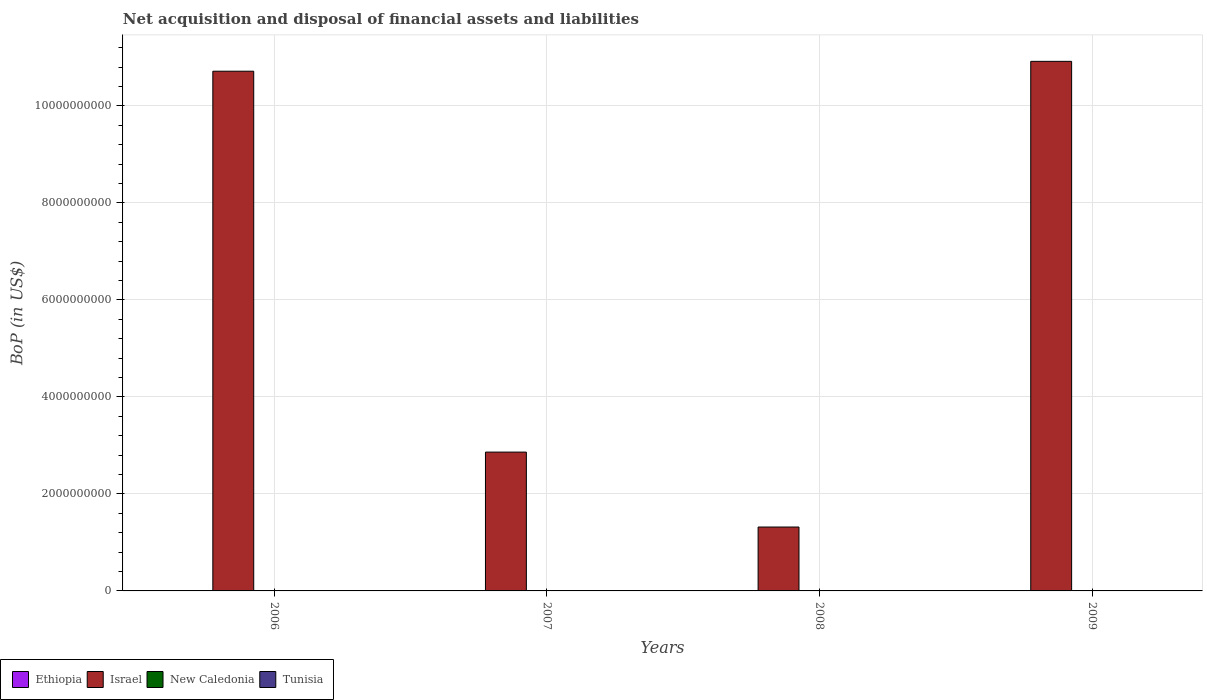Are the number of bars per tick equal to the number of legend labels?
Offer a very short reply. No. How many bars are there on the 4th tick from the left?
Your response must be concise. 1. How many bars are there on the 3rd tick from the right?
Provide a succinct answer. 1. In how many cases, is the number of bars for a given year not equal to the number of legend labels?
Ensure brevity in your answer.  4. In which year was the Balance of Payments in Israel maximum?
Provide a short and direct response. 2009. What is the total Balance of Payments in Ethiopia in the graph?
Your response must be concise. 0. What is the difference between the Balance of Payments in Israel in 2006 and that in 2007?
Provide a succinct answer. 7.85e+09. What is the difference between the Balance of Payments in Israel in 2008 and the Balance of Payments in New Caledonia in 2006?
Offer a very short reply. 1.32e+09. In how many years, is the Balance of Payments in New Caledonia greater than 1200000000 US$?
Offer a very short reply. 0. What is the ratio of the Balance of Payments in Israel in 2007 to that in 2008?
Provide a succinct answer. 2.17. What is the difference between the highest and the lowest Balance of Payments in Israel?
Provide a short and direct response. 9.60e+09. Is it the case that in every year, the sum of the Balance of Payments in Israel and Balance of Payments in New Caledonia is greater than the sum of Balance of Payments in Tunisia and Balance of Payments in Ethiopia?
Your response must be concise. Yes. What is the difference between two consecutive major ticks on the Y-axis?
Offer a terse response. 2.00e+09. Are the values on the major ticks of Y-axis written in scientific E-notation?
Keep it short and to the point. No. Does the graph contain grids?
Ensure brevity in your answer.  Yes. Where does the legend appear in the graph?
Make the answer very short. Bottom left. How are the legend labels stacked?
Keep it short and to the point. Horizontal. What is the title of the graph?
Your response must be concise. Net acquisition and disposal of financial assets and liabilities. What is the label or title of the X-axis?
Offer a terse response. Years. What is the label or title of the Y-axis?
Provide a succinct answer. BoP (in US$). What is the BoP (in US$) in Ethiopia in 2006?
Keep it short and to the point. 0. What is the BoP (in US$) in Israel in 2006?
Keep it short and to the point. 1.07e+1. What is the BoP (in US$) in New Caledonia in 2006?
Offer a very short reply. 0. What is the BoP (in US$) of Ethiopia in 2007?
Offer a terse response. 0. What is the BoP (in US$) of Israel in 2007?
Provide a succinct answer. 2.86e+09. What is the BoP (in US$) of New Caledonia in 2007?
Keep it short and to the point. 0. What is the BoP (in US$) of Tunisia in 2007?
Give a very brief answer. 0. What is the BoP (in US$) of Ethiopia in 2008?
Ensure brevity in your answer.  0. What is the BoP (in US$) in Israel in 2008?
Give a very brief answer. 1.32e+09. What is the BoP (in US$) in New Caledonia in 2008?
Your answer should be very brief. 0. What is the BoP (in US$) of Israel in 2009?
Your answer should be compact. 1.09e+1. Across all years, what is the maximum BoP (in US$) of Israel?
Your answer should be very brief. 1.09e+1. Across all years, what is the minimum BoP (in US$) in Israel?
Keep it short and to the point. 1.32e+09. What is the total BoP (in US$) of Ethiopia in the graph?
Provide a succinct answer. 0. What is the total BoP (in US$) in Israel in the graph?
Offer a very short reply. 2.58e+1. What is the total BoP (in US$) in New Caledonia in the graph?
Offer a very short reply. 0. What is the difference between the BoP (in US$) in Israel in 2006 and that in 2007?
Give a very brief answer. 7.85e+09. What is the difference between the BoP (in US$) in Israel in 2006 and that in 2008?
Ensure brevity in your answer.  9.40e+09. What is the difference between the BoP (in US$) of Israel in 2006 and that in 2009?
Make the answer very short. -2.03e+08. What is the difference between the BoP (in US$) of Israel in 2007 and that in 2008?
Your answer should be very brief. 1.54e+09. What is the difference between the BoP (in US$) of Israel in 2007 and that in 2009?
Ensure brevity in your answer.  -8.06e+09. What is the difference between the BoP (in US$) of Israel in 2008 and that in 2009?
Your answer should be compact. -9.60e+09. What is the average BoP (in US$) in Ethiopia per year?
Provide a short and direct response. 0. What is the average BoP (in US$) of Israel per year?
Keep it short and to the point. 6.45e+09. What is the ratio of the BoP (in US$) in Israel in 2006 to that in 2007?
Keep it short and to the point. 3.74. What is the ratio of the BoP (in US$) of Israel in 2006 to that in 2008?
Give a very brief answer. 8.13. What is the ratio of the BoP (in US$) of Israel in 2006 to that in 2009?
Provide a short and direct response. 0.98. What is the ratio of the BoP (in US$) in Israel in 2007 to that in 2008?
Ensure brevity in your answer.  2.17. What is the ratio of the BoP (in US$) in Israel in 2007 to that in 2009?
Keep it short and to the point. 0.26. What is the ratio of the BoP (in US$) of Israel in 2008 to that in 2009?
Offer a very short reply. 0.12. What is the difference between the highest and the second highest BoP (in US$) in Israel?
Offer a very short reply. 2.03e+08. What is the difference between the highest and the lowest BoP (in US$) of Israel?
Provide a succinct answer. 9.60e+09. 